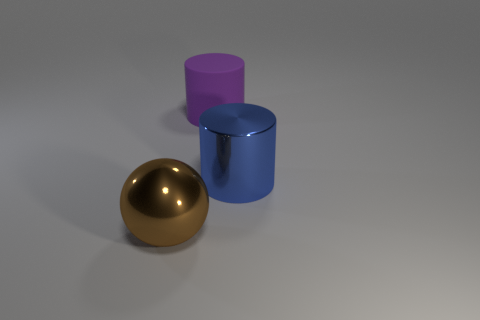Subtract all cylinders. How many objects are left? 1 Subtract all blue cylinders. How many cylinders are left? 1 Subtract 1 cylinders. How many cylinders are left? 1 Subtract all blue cylinders. Subtract all yellow blocks. How many cylinders are left? 1 Subtract all green balls. How many blue cylinders are left? 1 Subtract all blue cylinders. Subtract all purple matte objects. How many objects are left? 1 Add 1 brown objects. How many brown objects are left? 2 Add 1 big spheres. How many big spheres exist? 2 Add 2 large cyan cylinders. How many objects exist? 5 Subtract 0 brown cylinders. How many objects are left? 3 